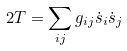Convert formula to latex. <formula><loc_0><loc_0><loc_500><loc_500>2 T = \sum _ { i j } g _ { i j } \dot { s } _ { i } \dot { s } _ { j }</formula> 